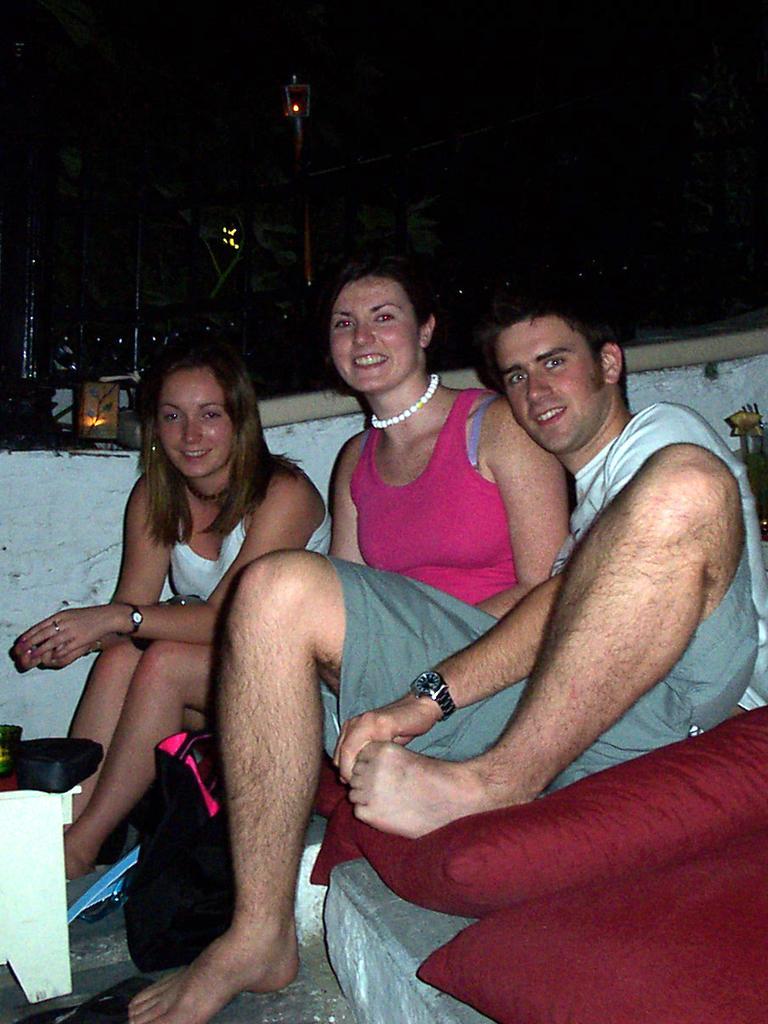Can you describe this image briefly? In the image in the center, we can see one table, pillows and three persons are sitting and smiling. In the background we can see poles, lights etc. 